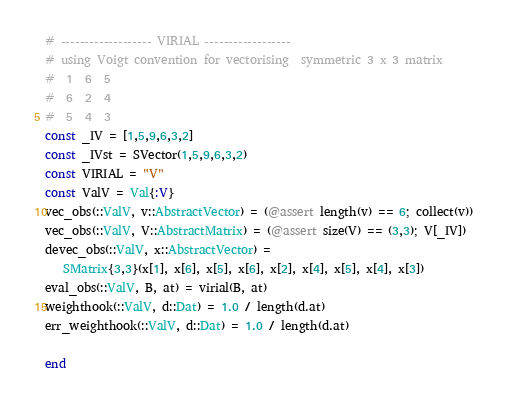Convert code to text. <code><loc_0><loc_0><loc_500><loc_500><_Julia_># ------------------- VIRIAL ------------------
# using Voigt convention for vectorising  symmetric 3 x 3 matrix
#  1  6  5
#  6  2  4
#  5  4  3
const _IV = [1,5,9,6,3,2]
const _IVst = SVector(1,5,9,6,3,2)
const VIRIAL = "V"
const ValV = Val{:V}
vec_obs(::ValV, v::AbstractVector) = (@assert length(v) == 6; collect(v))
vec_obs(::ValV, V::AbstractMatrix) = (@assert size(V) == (3,3); V[_IV])
devec_obs(::ValV, x::AbstractVector) =
   SMatrix{3,3}(x[1], x[6], x[5], x[6], x[2], x[4], x[5], x[4], x[3])
eval_obs(::ValV, B, at) = virial(B, at)
weighthook(::ValV, d::Dat) = 1.0 / length(d.at)
err_weighthook(::ValV, d::Dat) = 1.0 / length(d.at)

end
</code> 